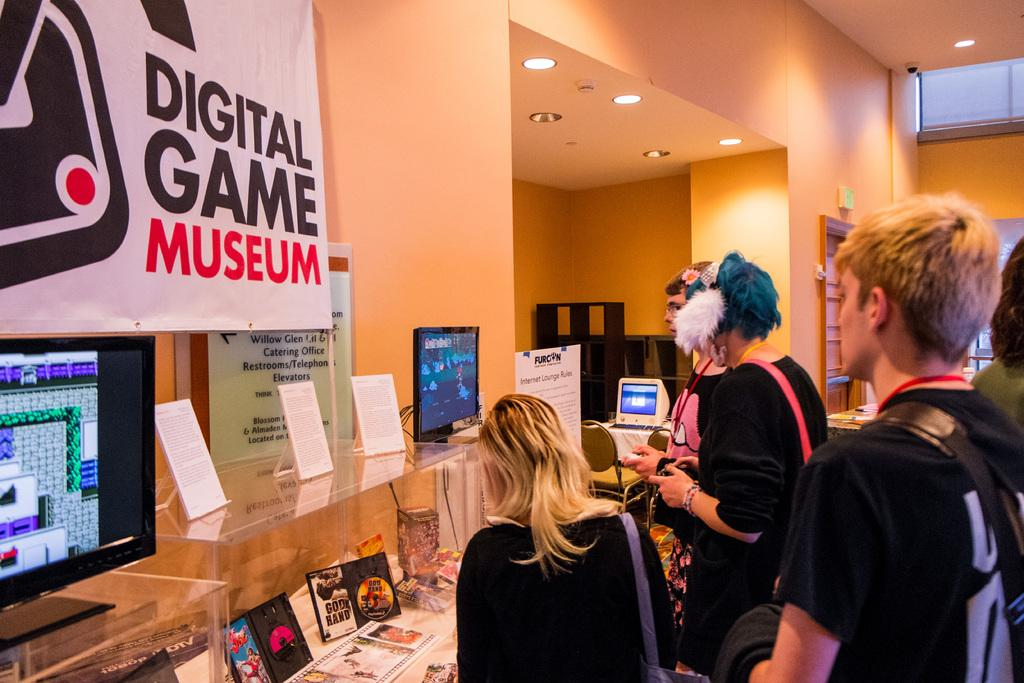What can be seen in the image involving people? There are people standing in the image. What objects are present on the table in the image? There are monitors and CD copies on the table. What type of decorations are on the wall in the image? There are banners on the wall. How many hands are visible holding the glass in the image? There is no glass or hands visible in the image. What type of bubble is floating near the banners in the image? There is no bubble present in the image. 